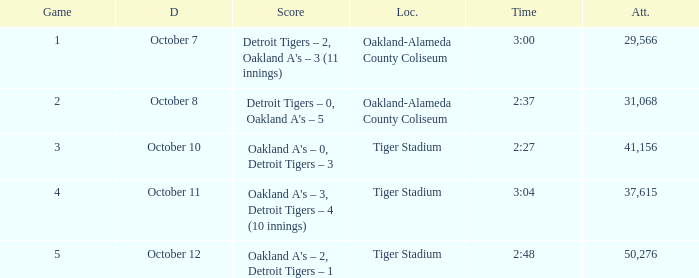What was the score at Tiger Stadium on October 12? Oakland A's – 2, Detroit Tigers – 1. I'm looking to parse the entire table for insights. Could you assist me with that? {'header': ['Game', 'D', 'Score', 'Loc.', 'Time', 'Att.'], 'rows': [['1', 'October 7', "Detroit Tigers – 2, Oakland A's – 3 (11 innings)", 'Oakland-Alameda County Coliseum', '3:00', '29,566'], ['2', 'October 8', "Detroit Tigers – 0, Oakland A's – 5", 'Oakland-Alameda County Coliseum', '2:37', '31,068'], ['3', 'October 10', "Oakland A's – 0, Detroit Tigers – 3", 'Tiger Stadium', '2:27', '41,156'], ['4', 'October 11', "Oakland A's – 3, Detroit Tigers – 4 (10 innings)", 'Tiger Stadium', '3:04', '37,615'], ['5', 'October 12', "Oakland A's – 2, Detroit Tigers – 1", 'Tiger Stadium', '2:48', '50,276']]} 